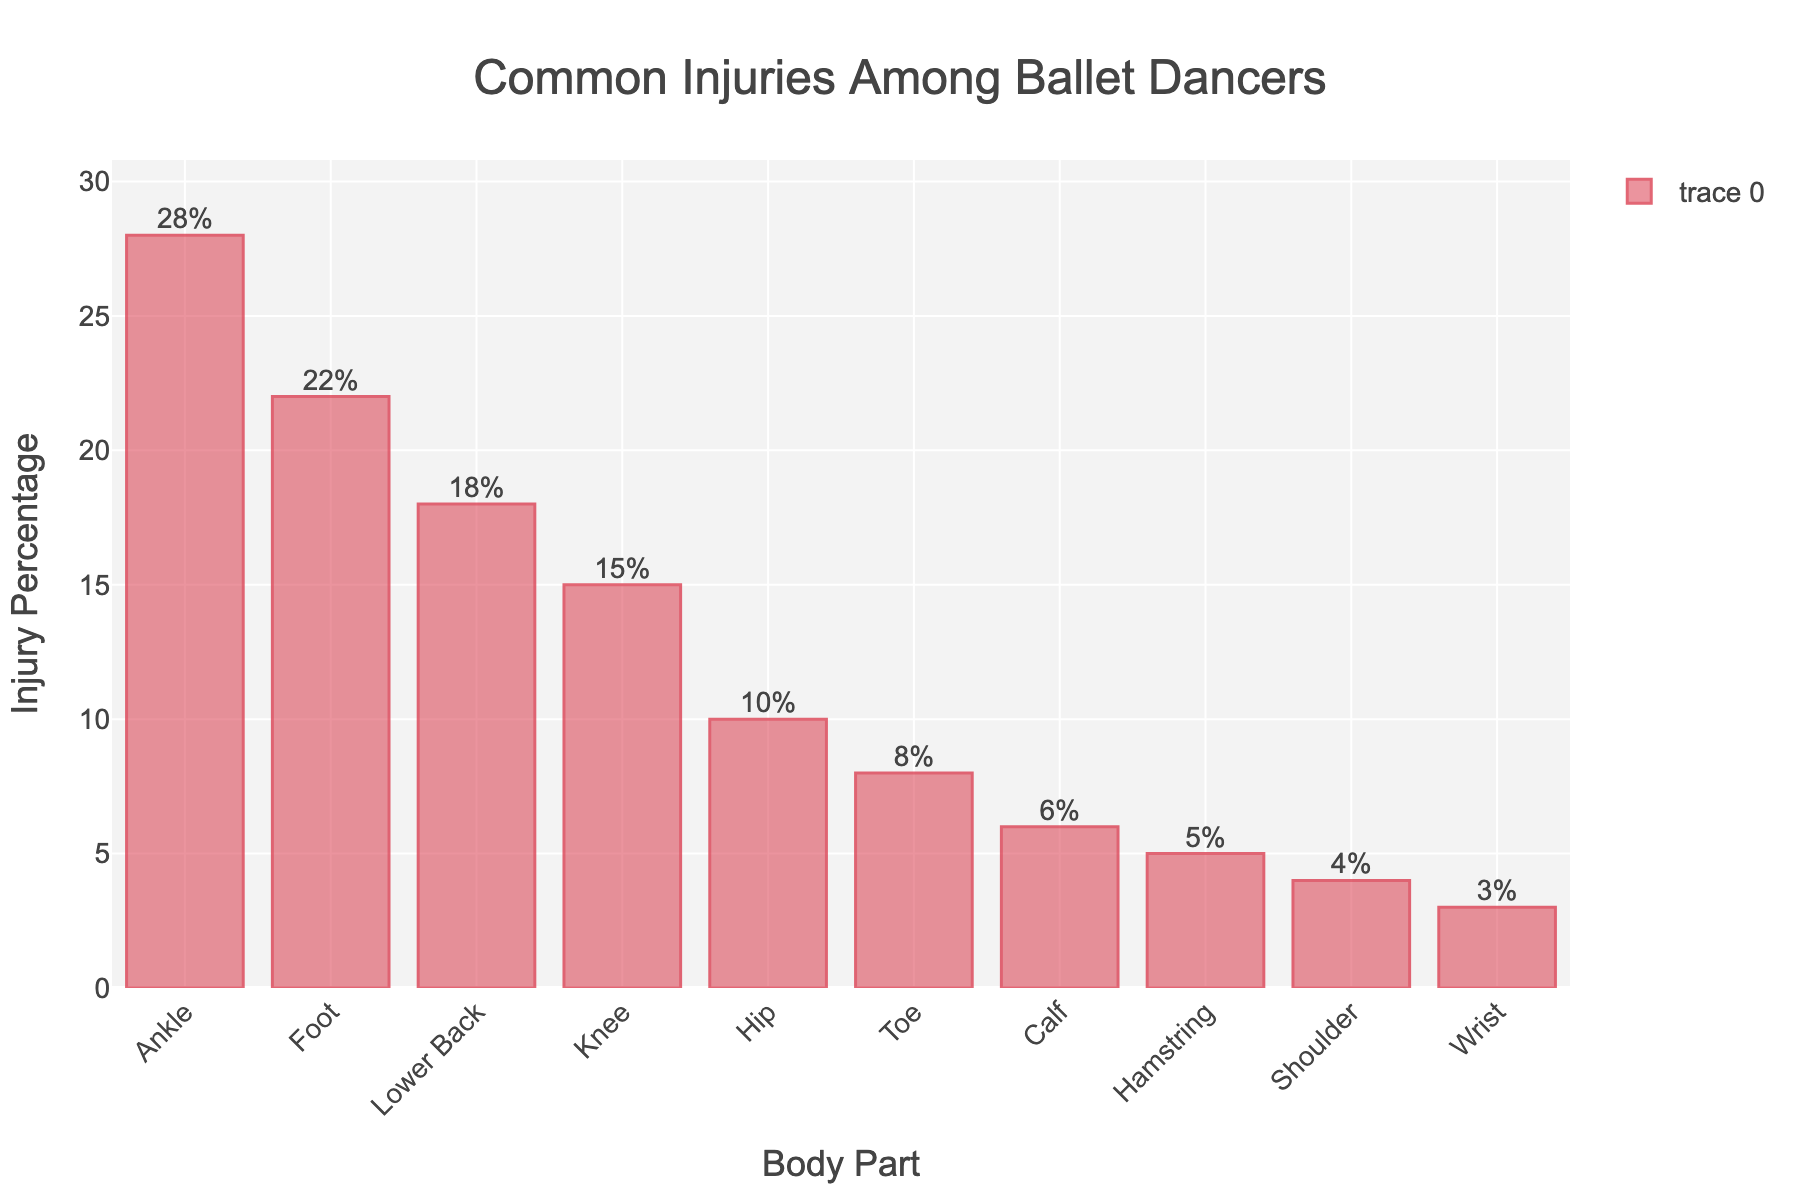Which body part experiences the highest percentage of injuries? The bar representing the ankle is the tallest and reads 28%, indicating it has the highest injury percentage.
Answer: Ankle Which two body parts combined account for 40% of the injuries? Lower back and Knee have injury percentages of 18% and 15% respectively. Adding these together gives 18 + 15 = 33%, which is the closest combination to the specified 40%.
Answer: Lower Back, Knee What is the difference in injury percentage between the shoulder and wrist? The shoulder has an injury percentage of 4%, and the wrist has 3%. Subtracting 3 from 4 gives us the difference.
Answer: 1% Among the listed body parts, which ones have an injury percentage less than 10%? The visually shorter bars correspond to Toe, Calf, Hamstring, Shoulder, and Wrist with values of 8%, 6%, 5%, 4%, and 3% respectively.
Answer: Toe, Calf, Hamstring, Shoulder, Wrist Which body part suffers more injuries, the hip or the toe, and by how much? The Hip bar height is at 10%, and the Toe at 8%. Subtracting 8 from 10 gives us the difference.
Answer: Hip by 2% What is the total percentage of injuries accounted for by the ankle, foot, and hip combined? Adding the injury percentages of the ankle (28%), foot (22%), and hip (10%) gives us 28 + 22 + 10. The sum is 60%.
Answer: 60% How much higher is the injury percentage for the foot compared to the hamstring? Foot has an injury percentage of 22% and the hamstring has 5%. Subtracting 5 from 22 gives us the difference.
Answer: 17% Arrange the body parts in ascending order of injury percentage. Listing the injury percentages in ascending order and then mapping to the corresponding body parts: Wrist (3%), Shoulder (4%), Hamstring (5%), Calf (6%), Toe (8%), Hip (10%), Knee (15%), Lower Back (18%), Foot (22%), and Ankle (28%).
Answer: Wrist, Shoulder, Hamstring, Calf, Toe, Hip, Knee, Lower Back, Foot, Ankle What is the average injury percentage among all listed body parts? Adding all injury percentages together (3+4+5+6+8+10+15+18+22+28) and then dividing by the number of data points (10) gives us the average. The sum is 119, dividing by 10 yields 11.9%.
Answer: 11.9% Which body part has slightly more than half the injury percentage of the ankle? The ankle has 28%, and half of 28 is 14. Looking at the list, the knee's bar is the closest, with an injury percentage of 15%, which is just over half.
Answer: Knee 